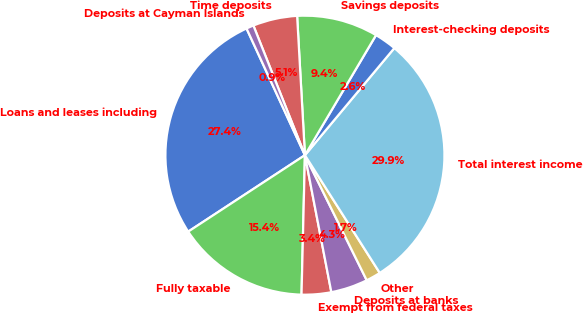Convert chart to OTSL. <chart><loc_0><loc_0><loc_500><loc_500><pie_chart><fcel>Loans and leases including<fcel>Fully taxable<fcel>Exempt from federal taxes<fcel>Deposits at banks<fcel>Other<fcel>Total interest income<fcel>Interest-checking deposits<fcel>Savings deposits<fcel>Time deposits<fcel>Deposits at Cayman Islands<nl><fcel>27.35%<fcel>15.38%<fcel>3.42%<fcel>4.27%<fcel>1.71%<fcel>29.91%<fcel>2.56%<fcel>9.4%<fcel>5.13%<fcel>0.85%<nl></chart> 